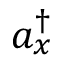Convert formula to latex. <formula><loc_0><loc_0><loc_500><loc_500>a _ { x } ^ { \dagger }</formula> 